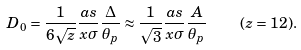<formula> <loc_0><loc_0><loc_500><loc_500>D _ { 0 } = \frac { 1 } { 6 \sqrt { z } } \frac { a s } { x \sigma } \frac { \Delta } { \theta _ { p } } \approx \frac { 1 } { \sqrt { 3 } } \frac { a s } { x \sigma } \frac { A } { \theta _ { p } } \quad ( z = 1 2 ) .</formula> 